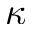Convert formula to latex. <formula><loc_0><loc_0><loc_500><loc_500>\kappa</formula> 